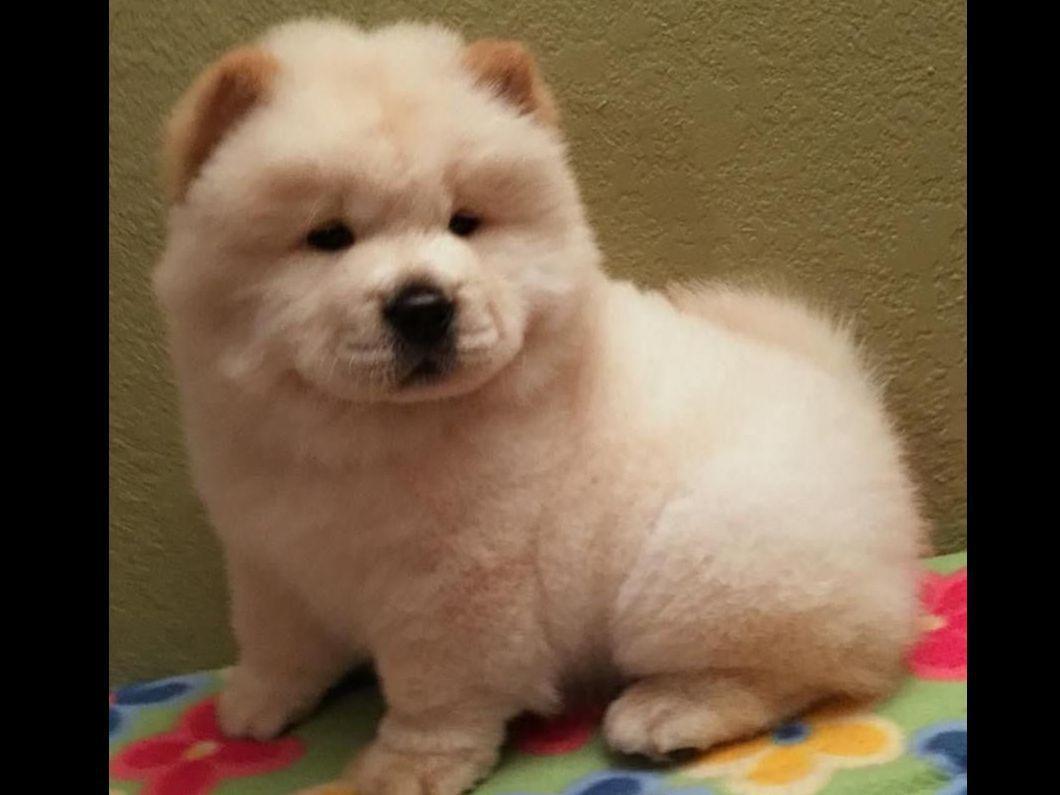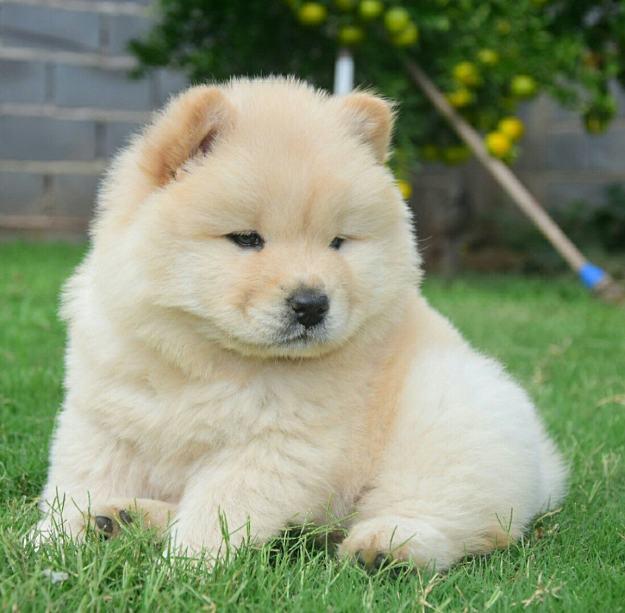The first image is the image on the left, the second image is the image on the right. Assess this claim about the two images: "Both images feature young chow puppies, and the puppies on the left and right share similar poses with bodies turned in the same direction, but the puppy on the left is not on grass.". Correct or not? Answer yes or no. Yes. The first image is the image on the left, the second image is the image on the right. Examine the images to the left and right. Is the description "Both of the images feature a dog standing on grass." accurate? Answer yes or no. No. 